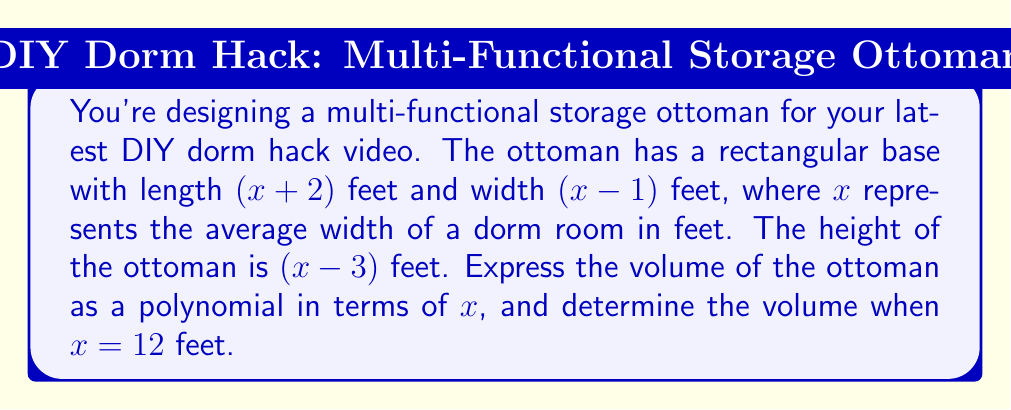Show me your answer to this math problem. To solve this problem, we need to follow these steps:

1) The volume of a rectangular prism is given by the formula:
   $V = length \times width \times height$

2) Substituting our dimensions:
   $V = (x+2)(x-1)(x-3)$

3) To expand this, we need to use polynomial multiplication:

   $$(x+2)(x-1) = x^2 - x + 2x - 2 = x^2 + x - 2$$

   Now multiply this result by $(x-3)$:

   $$(x^2 + x - 2)(x-3) = x^3 - 3x^2 + x^2 - 3x - 2x + 6$$
                        $$= x^3 - 2x^2 - 5x + 6$$

4) Therefore, the volume as a polynomial in terms of $x$ is:
   $$V = x^3 - 2x^2 - 5x + 6$$

5) To find the volume when $x = 12$, we substitute 12 for $x$:

   $$V = 12^3 - 2(12^2) - 5(12) + 6$$
      $$= 1728 - 288 - 60 + 6$$
      $$= 1386$$

Thus, when the average width of a dorm room is 12 feet, the volume of the ottoman is 1386 cubic feet.
Answer: The volume of the ottoman as a polynomial in terms of $x$ is $V = x^3 - 2x^2 - 5x + 6$ cubic feet. When $x = 12$ feet, the volume is 1386 cubic feet. 